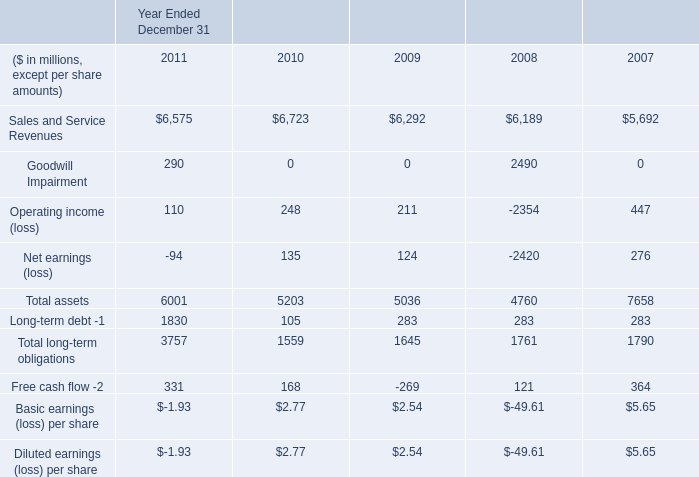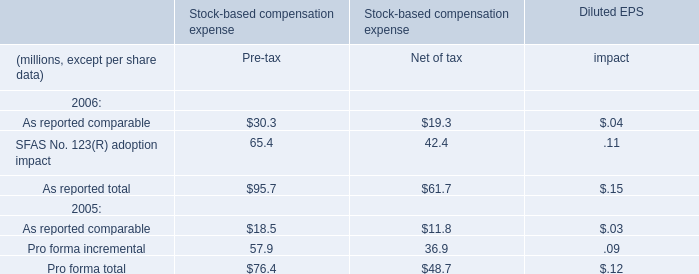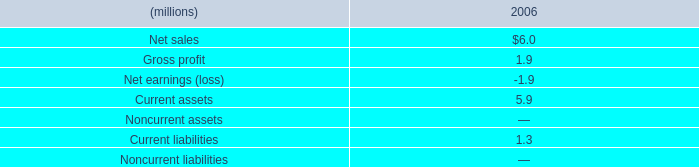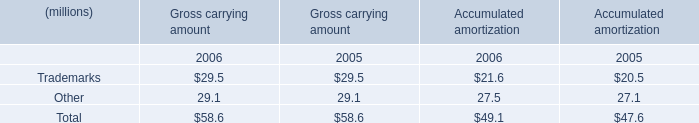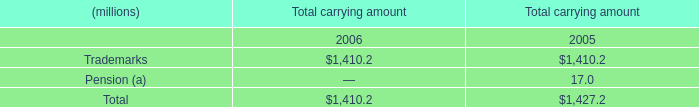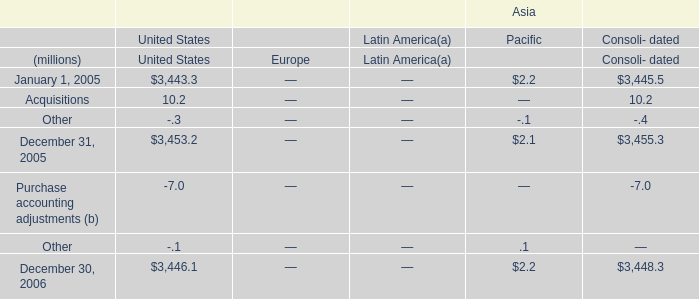How many Consoli- dated exceed the average of Consoli- dated in 2005? 
Answer: 1. 